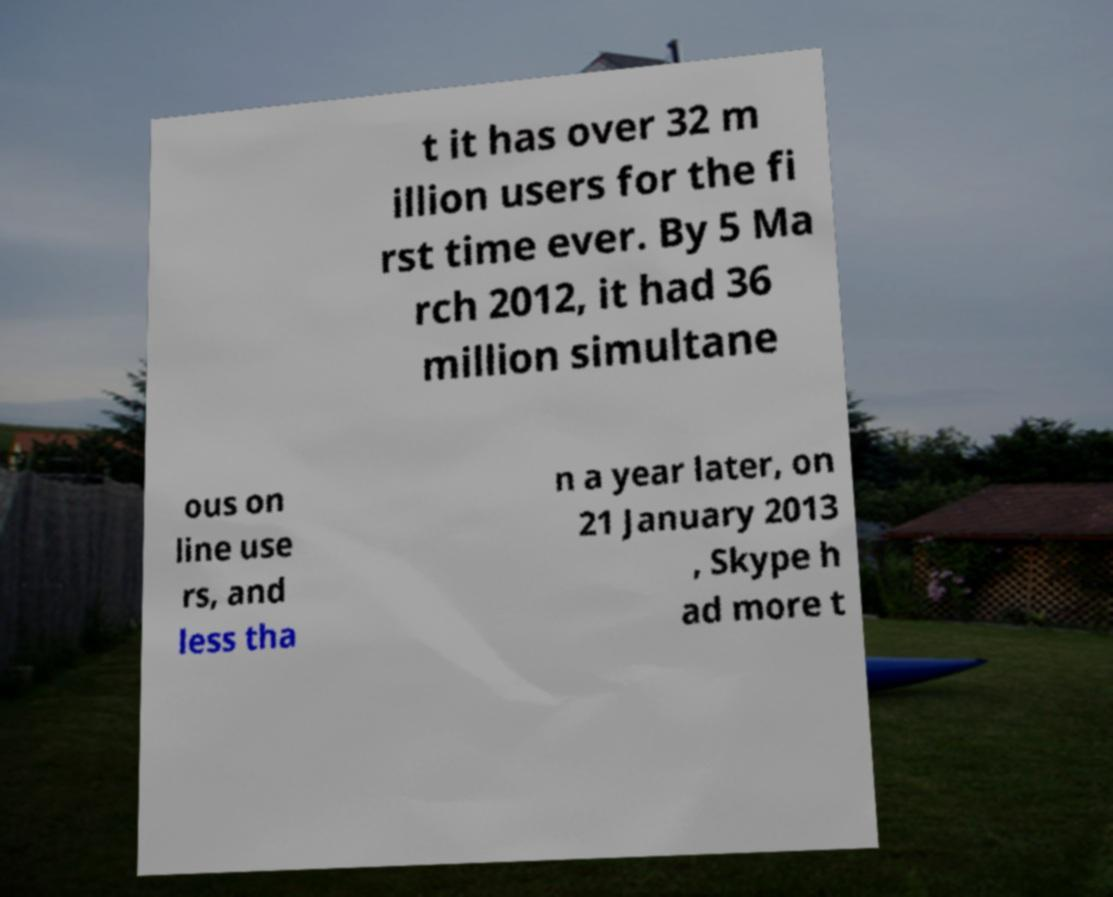Can you accurately transcribe the text from the provided image for me? t it has over 32 m illion users for the fi rst time ever. By 5 Ma rch 2012, it had 36 million simultane ous on line use rs, and less tha n a year later, on 21 January 2013 , Skype h ad more t 